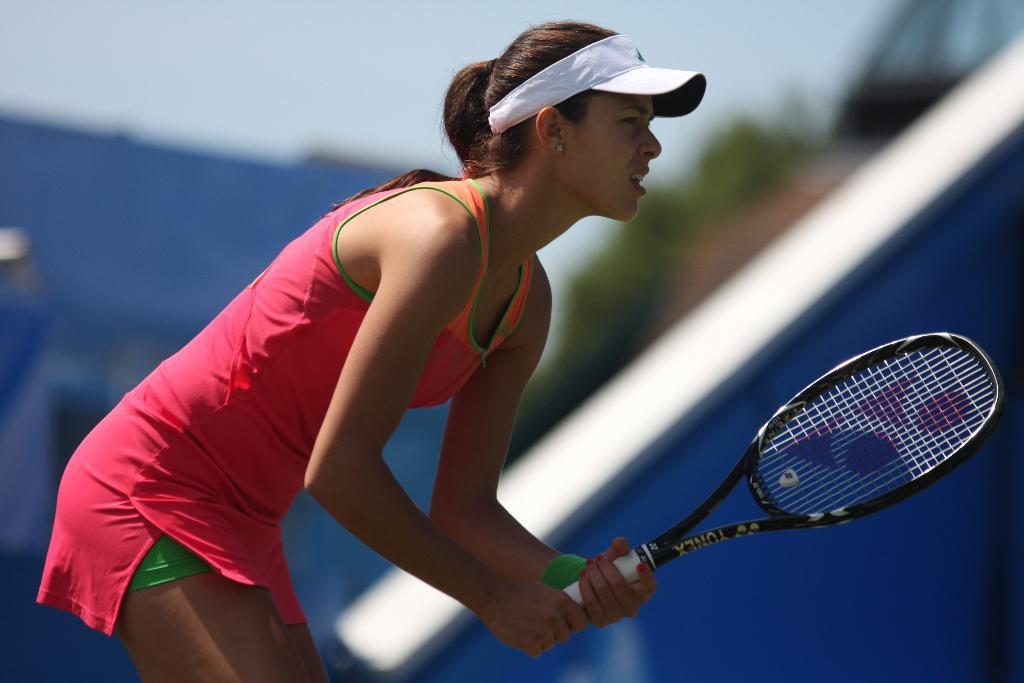Who is in the picture? There is a woman in the picture. What is the woman doing in the picture? The woman is standing and holding a tennis bat. What is the woman wearing on her head? The woman is wearing a white color hat. What is the woman wearing on her body? The woman is wearing a pink color dress. What can be seen in the background of the picture? There is a tennis court and the sky visible in the background of the picture. How much money is the woman holding in the picture? The woman is not holding any money in the picture; she is holding a tennis bat. What type of flowers can be seen growing on the tennis court in the image? There are no flowers visible on the tennis court in the image. 